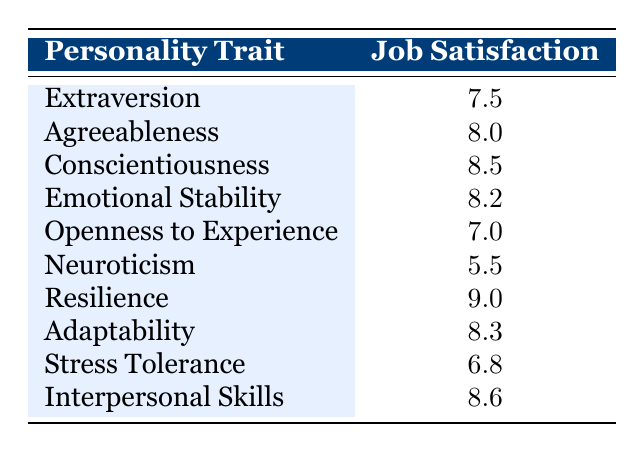What is the job satisfaction score for Conscientiousness? The table directly provides the job satisfaction score associated with Conscientiousness, which is listed as 8.5.
Answer: 8.5 Which personality trait has the highest job satisfaction? By comparing the job satisfaction scores in the table, we identify that Resilience has the highest score at 9.0, higher than all other traits listed.
Answer: Resilience Is the job satisfaction for Extraversion higher than for Neuroticism? Comparing the scores in the table, Extraversion has a job satisfaction score of 7.5 while Neuroticism is lower at 5.5. Thus, Extraversion's score is indeed higher.
Answer: Yes What is the average job satisfaction score for traits associated with adaptability (Adaptability, Emotional Stability, and Stress Tolerance)? First, we extract the job satisfaction scores: Adaptability (8.3), Emotional Stability (8.2), and Stress Tolerance (6.8). Adding these gives 8.3 + 8.2 + 6.8 = 23.3. We divide this by the number of traits (3) to find the average, which is 23.3 / 3 = 7.77.
Answer: 7.77 Is it true that all personality traits except Neuroticism score above 7 in job satisfaction? By examining the table, we check each score: Extraversion (7.5), Agreeableness (8.0), Conscientiousness (8.5), Emotional Stability (8.2), Openness to Experience (7.0), Resilience (9.0), Adaptability (8.3), and Interpersonal Skills (8.6) are all above 7, while Neuroticism (5.5) is below 7. Thus, the statement is false.
Answer: No What is the difference in job satisfaction between Resilience and Neuroticism? The job satisfaction scores from the table show that Resilience is 9.0 and Neuroticism is 5.5. To find the difference, we subtract: 9.0 - 5.5 = 3.5.
Answer: 3.5 Which personality trait has the closest job satisfaction score to Openness to Experience? The job satisfaction score for Openness to Experience is 7.0. Comparing this to others: Extraversion (7.5) is the closest to 7.0, differing by only 0.5.
Answer: Extraversion What is the total job satisfaction score for all personality traits listed in the table? Summing all job satisfaction scores: 7.5 + 8.0 + 8.5 + 8.2 + 7.0 + 5.5 + 9.0 + 8.3 + 6.8 + 8.6 = 78.4 gives the total job satisfaction score.
Answer: 78.4 